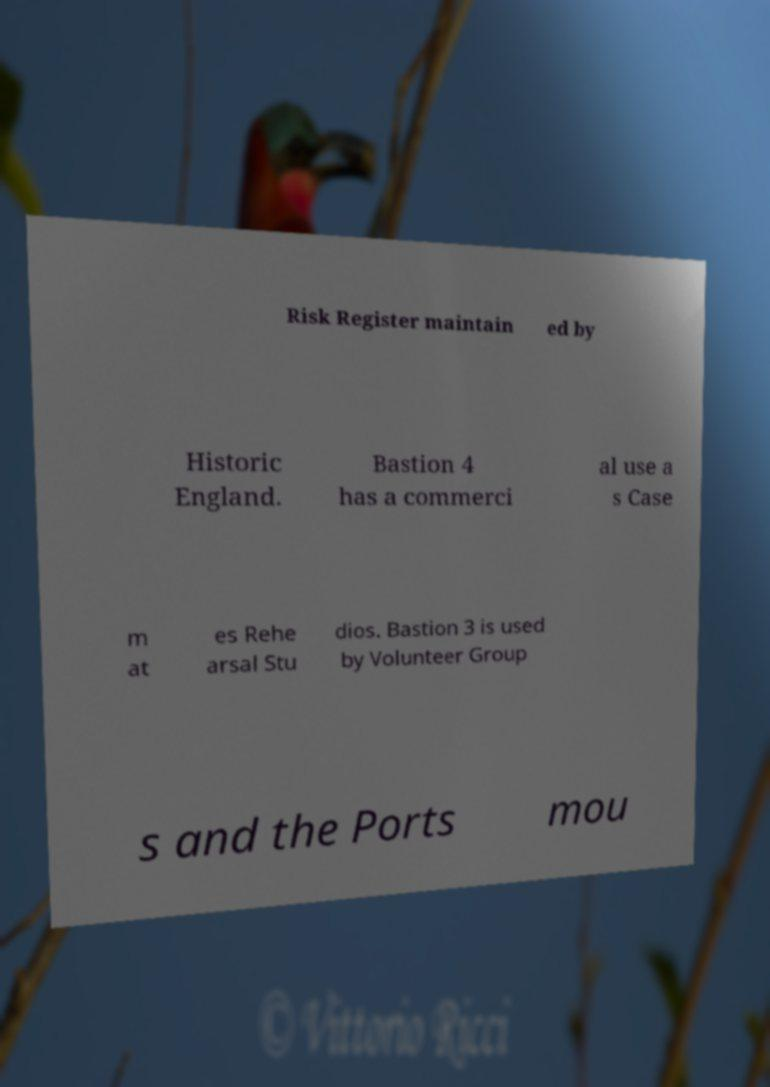Could you extract and type out the text from this image? Risk Register maintain ed by Historic England. Bastion 4 has a commerci al use a s Case m at es Rehe arsal Stu dios. Bastion 3 is used by Volunteer Group s and the Ports mou 